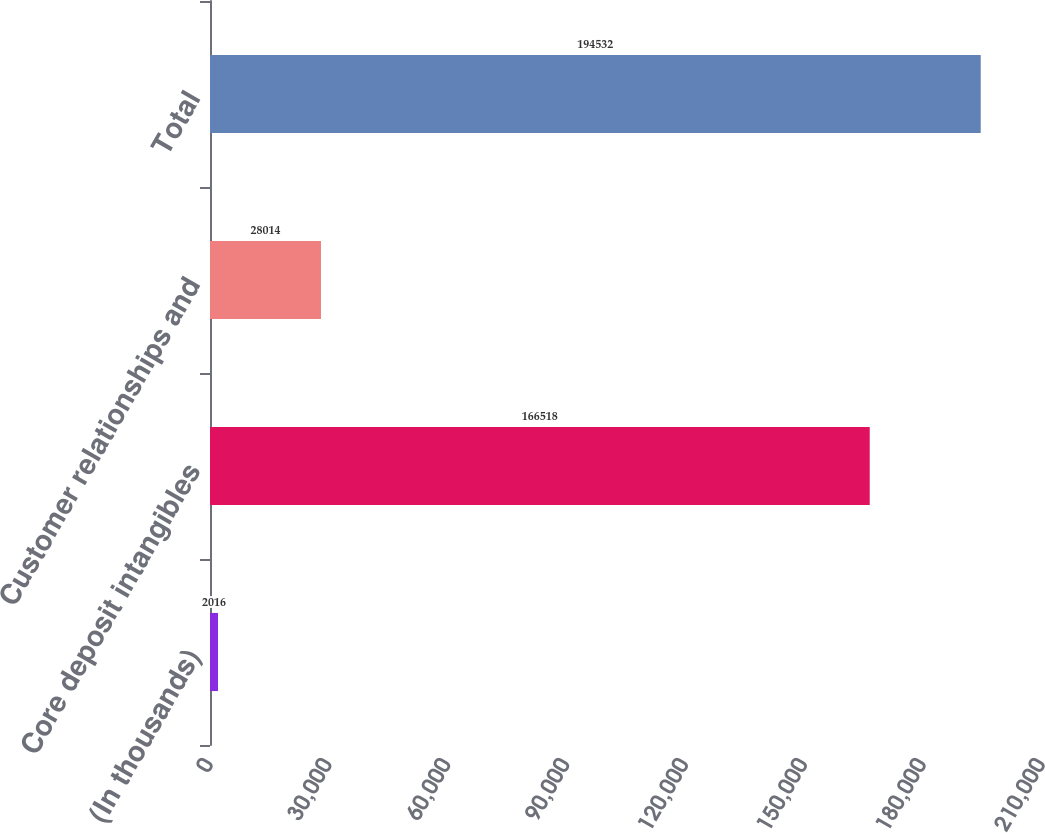<chart> <loc_0><loc_0><loc_500><loc_500><bar_chart><fcel>(In thousands)<fcel>Core deposit intangibles<fcel>Customer relationships and<fcel>Total<nl><fcel>2016<fcel>166518<fcel>28014<fcel>194532<nl></chart> 